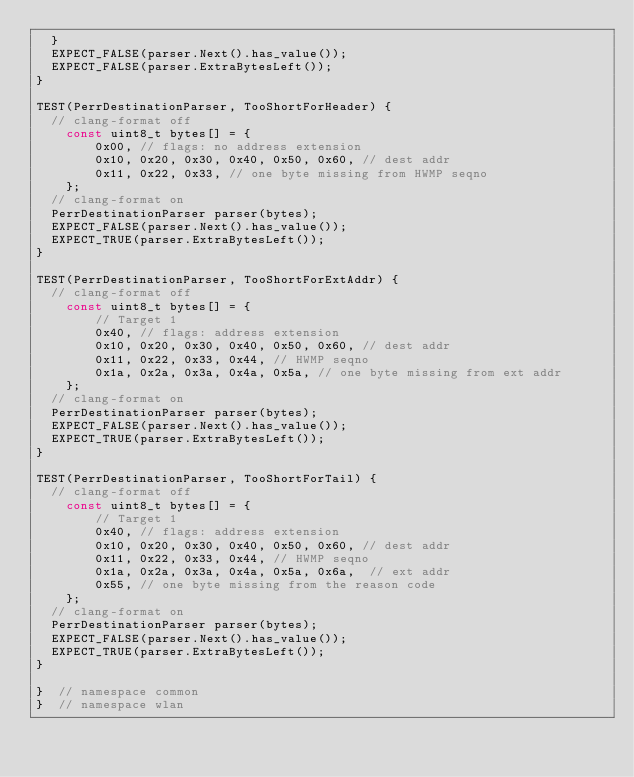Convert code to text. <code><loc_0><loc_0><loc_500><loc_500><_C++_>  }
  EXPECT_FALSE(parser.Next().has_value());
  EXPECT_FALSE(parser.ExtraBytesLeft());
}

TEST(PerrDestinationParser, TooShortForHeader) {
  // clang-format off
    const uint8_t bytes[] = {
        0x00, // flags: no address extension
        0x10, 0x20, 0x30, 0x40, 0x50, 0x60, // dest addr
        0x11, 0x22, 0x33, // one byte missing from HWMP seqno
    };
  // clang-format on
  PerrDestinationParser parser(bytes);
  EXPECT_FALSE(parser.Next().has_value());
  EXPECT_TRUE(parser.ExtraBytesLeft());
}

TEST(PerrDestinationParser, TooShortForExtAddr) {
  // clang-format off
    const uint8_t bytes[] = {
        // Target 1
        0x40, // flags: address extension
        0x10, 0x20, 0x30, 0x40, 0x50, 0x60, // dest addr
        0x11, 0x22, 0x33, 0x44, // HWMP seqno
        0x1a, 0x2a, 0x3a, 0x4a, 0x5a, // one byte missing from ext addr
    };
  // clang-format on
  PerrDestinationParser parser(bytes);
  EXPECT_FALSE(parser.Next().has_value());
  EXPECT_TRUE(parser.ExtraBytesLeft());
}

TEST(PerrDestinationParser, TooShortForTail) {
  // clang-format off
    const uint8_t bytes[] = {
        // Target 1
        0x40, // flags: address extension
        0x10, 0x20, 0x30, 0x40, 0x50, 0x60, // dest addr
        0x11, 0x22, 0x33, 0x44, // HWMP seqno
        0x1a, 0x2a, 0x3a, 0x4a, 0x5a, 0x6a,  // ext addr
        0x55, // one byte missing from the reason code
    };
  // clang-format on
  PerrDestinationParser parser(bytes);
  EXPECT_FALSE(parser.Next().has_value());
  EXPECT_TRUE(parser.ExtraBytesLeft());
}

}  // namespace common
}  // namespace wlan
</code> 